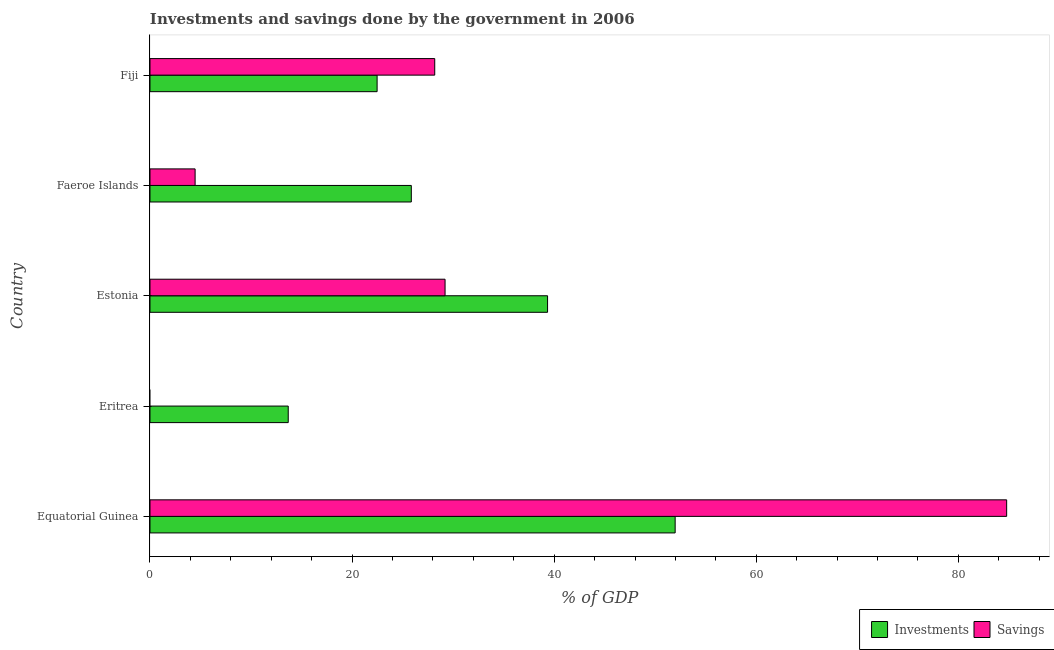Are the number of bars per tick equal to the number of legend labels?
Offer a very short reply. No. Are the number of bars on each tick of the Y-axis equal?
Keep it short and to the point. No. How many bars are there on the 3rd tick from the top?
Keep it short and to the point. 2. What is the label of the 3rd group of bars from the top?
Your response must be concise. Estonia. What is the savings of government in Equatorial Guinea?
Provide a succinct answer. 84.78. Across all countries, what is the maximum investments of government?
Provide a succinct answer. 51.97. In which country was the savings of government maximum?
Provide a short and direct response. Equatorial Guinea. What is the total investments of government in the graph?
Provide a succinct answer. 153.34. What is the difference between the savings of government in Estonia and that in Fiji?
Ensure brevity in your answer.  1.02. What is the difference between the investments of government in Estonia and the savings of government in Faeroe Islands?
Offer a very short reply. 34.88. What is the average savings of government per country?
Provide a short and direct response. 29.33. What is the difference between the investments of government and savings of government in Faeroe Islands?
Ensure brevity in your answer.  21.4. In how many countries, is the savings of government greater than 8 %?
Provide a short and direct response. 3. What is the ratio of the investments of government in Estonia to that in Fiji?
Your answer should be very brief. 1.75. What is the difference between the highest and the second highest investments of government?
Provide a succinct answer. 12.63. What is the difference between the highest and the lowest investments of government?
Keep it short and to the point. 38.29. In how many countries, is the savings of government greater than the average savings of government taken over all countries?
Your answer should be compact. 1. Is the sum of the investments of government in Eritrea and Faeroe Islands greater than the maximum savings of government across all countries?
Provide a short and direct response. No. How many bars are there?
Offer a very short reply. 9. What is the difference between two consecutive major ticks on the X-axis?
Keep it short and to the point. 20. How many legend labels are there?
Ensure brevity in your answer.  2. What is the title of the graph?
Provide a succinct answer. Investments and savings done by the government in 2006. What is the label or title of the X-axis?
Provide a succinct answer. % of GDP. What is the % of GDP in Investments in Equatorial Guinea?
Provide a succinct answer. 51.97. What is the % of GDP in Savings in Equatorial Guinea?
Provide a succinct answer. 84.78. What is the % of GDP of Investments in Eritrea?
Keep it short and to the point. 13.68. What is the % of GDP of Investments in Estonia?
Make the answer very short. 39.35. What is the % of GDP of Savings in Estonia?
Your answer should be very brief. 29.2. What is the % of GDP in Investments in Faeroe Islands?
Your answer should be compact. 25.86. What is the % of GDP in Savings in Faeroe Islands?
Your answer should be very brief. 4.47. What is the % of GDP in Investments in Fiji?
Your answer should be compact. 22.48. What is the % of GDP of Savings in Fiji?
Your answer should be very brief. 28.18. Across all countries, what is the maximum % of GDP of Investments?
Your response must be concise. 51.97. Across all countries, what is the maximum % of GDP in Savings?
Keep it short and to the point. 84.78. Across all countries, what is the minimum % of GDP of Investments?
Provide a short and direct response. 13.68. What is the total % of GDP in Investments in the graph?
Provide a succinct answer. 153.34. What is the total % of GDP in Savings in the graph?
Your response must be concise. 146.63. What is the difference between the % of GDP of Investments in Equatorial Guinea and that in Eritrea?
Provide a succinct answer. 38.29. What is the difference between the % of GDP of Investments in Equatorial Guinea and that in Estonia?
Provide a succinct answer. 12.63. What is the difference between the % of GDP in Savings in Equatorial Guinea and that in Estonia?
Your answer should be compact. 55.58. What is the difference between the % of GDP in Investments in Equatorial Guinea and that in Faeroe Islands?
Give a very brief answer. 26.11. What is the difference between the % of GDP of Savings in Equatorial Guinea and that in Faeroe Islands?
Your answer should be very brief. 80.32. What is the difference between the % of GDP of Investments in Equatorial Guinea and that in Fiji?
Offer a very short reply. 29.5. What is the difference between the % of GDP in Savings in Equatorial Guinea and that in Fiji?
Provide a short and direct response. 56.6. What is the difference between the % of GDP in Investments in Eritrea and that in Estonia?
Make the answer very short. -25.67. What is the difference between the % of GDP of Investments in Eritrea and that in Faeroe Islands?
Offer a terse response. -12.18. What is the difference between the % of GDP in Investments in Eritrea and that in Fiji?
Offer a very short reply. -8.8. What is the difference between the % of GDP of Investments in Estonia and that in Faeroe Islands?
Offer a terse response. 13.48. What is the difference between the % of GDP of Savings in Estonia and that in Faeroe Islands?
Give a very brief answer. 24.74. What is the difference between the % of GDP of Investments in Estonia and that in Fiji?
Give a very brief answer. 16.87. What is the difference between the % of GDP of Savings in Estonia and that in Fiji?
Offer a very short reply. 1.02. What is the difference between the % of GDP of Investments in Faeroe Islands and that in Fiji?
Give a very brief answer. 3.39. What is the difference between the % of GDP of Savings in Faeroe Islands and that in Fiji?
Keep it short and to the point. -23.72. What is the difference between the % of GDP in Investments in Equatorial Guinea and the % of GDP in Savings in Estonia?
Your answer should be very brief. 22.77. What is the difference between the % of GDP in Investments in Equatorial Guinea and the % of GDP in Savings in Faeroe Islands?
Offer a very short reply. 47.51. What is the difference between the % of GDP in Investments in Equatorial Guinea and the % of GDP in Savings in Fiji?
Keep it short and to the point. 23.79. What is the difference between the % of GDP in Investments in Eritrea and the % of GDP in Savings in Estonia?
Your response must be concise. -15.52. What is the difference between the % of GDP of Investments in Eritrea and the % of GDP of Savings in Faeroe Islands?
Provide a short and direct response. 9.22. What is the difference between the % of GDP in Investments in Eritrea and the % of GDP in Savings in Fiji?
Provide a short and direct response. -14.5. What is the difference between the % of GDP of Investments in Estonia and the % of GDP of Savings in Faeroe Islands?
Your answer should be very brief. 34.88. What is the difference between the % of GDP of Investments in Estonia and the % of GDP of Savings in Fiji?
Offer a very short reply. 11.17. What is the difference between the % of GDP of Investments in Faeroe Islands and the % of GDP of Savings in Fiji?
Provide a succinct answer. -2.32. What is the average % of GDP in Investments per country?
Give a very brief answer. 30.67. What is the average % of GDP of Savings per country?
Provide a succinct answer. 29.33. What is the difference between the % of GDP in Investments and % of GDP in Savings in Equatorial Guinea?
Provide a short and direct response. -32.81. What is the difference between the % of GDP in Investments and % of GDP in Savings in Estonia?
Make the answer very short. 10.14. What is the difference between the % of GDP in Investments and % of GDP in Savings in Faeroe Islands?
Keep it short and to the point. 21.4. What is the difference between the % of GDP of Investments and % of GDP of Savings in Fiji?
Make the answer very short. -5.7. What is the ratio of the % of GDP in Investments in Equatorial Guinea to that in Eritrea?
Give a very brief answer. 3.8. What is the ratio of the % of GDP in Investments in Equatorial Guinea to that in Estonia?
Give a very brief answer. 1.32. What is the ratio of the % of GDP in Savings in Equatorial Guinea to that in Estonia?
Your answer should be very brief. 2.9. What is the ratio of the % of GDP of Investments in Equatorial Guinea to that in Faeroe Islands?
Ensure brevity in your answer.  2.01. What is the ratio of the % of GDP of Savings in Equatorial Guinea to that in Faeroe Islands?
Provide a short and direct response. 18.99. What is the ratio of the % of GDP in Investments in Equatorial Guinea to that in Fiji?
Your response must be concise. 2.31. What is the ratio of the % of GDP in Savings in Equatorial Guinea to that in Fiji?
Offer a very short reply. 3.01. What is the ratio of the % of GDP of Investments in Eritrea to that in Estonia?
Your answer should be very brief. 0.35. What is the ratio of the % of GDP in Investments in Eritrea to that in Faeroe Islands?
Your answer should be very brief. 0.53. What is the ratio of the % of GDP in Investments in Eritrea to that in Fiji?
Your answer should be very brief. 0.61. What is the ratio of the % of GDP in Investments in Estonia to that in Faeroe Islands?
Provide a succinct answer. 1.52. What is the ratio of the % of GDP of Savings in Estonia to that in Faeroe Islands?
Offer a terse response. 6.54. What is the ratio of the % of GDP in Investments in Estonia to that in Fiji?
Your answer should be very brief. 1.75. What is the ratio of the % of GDP in Savings in Estonia to that in Fiji?
Your answer should be very brief. 1.04. What is the ratio of the % of GDP of Investments in Faeroe Islands to that in Fiji?
Offer a very short reply. 1.15. What is the ratio of the % of GDP of Savings in Faeroe Islands to that in Fiji?
Your answer should be compact. 0.16. What is the difference between the highest and the second highest % of GDP in Investments?
Make the answer very short. 12.63. What is the difference between the highest and the second highest % of GDP of Savings?
Your response must be concise. 55.58. What is the difference between the highest and the lowest % of GDP in Investments?
Your answer should be compact. 38.29. What is the difference between the highest and the lowest % of GDP in Savings?
Offer a terse response. 84.78. 